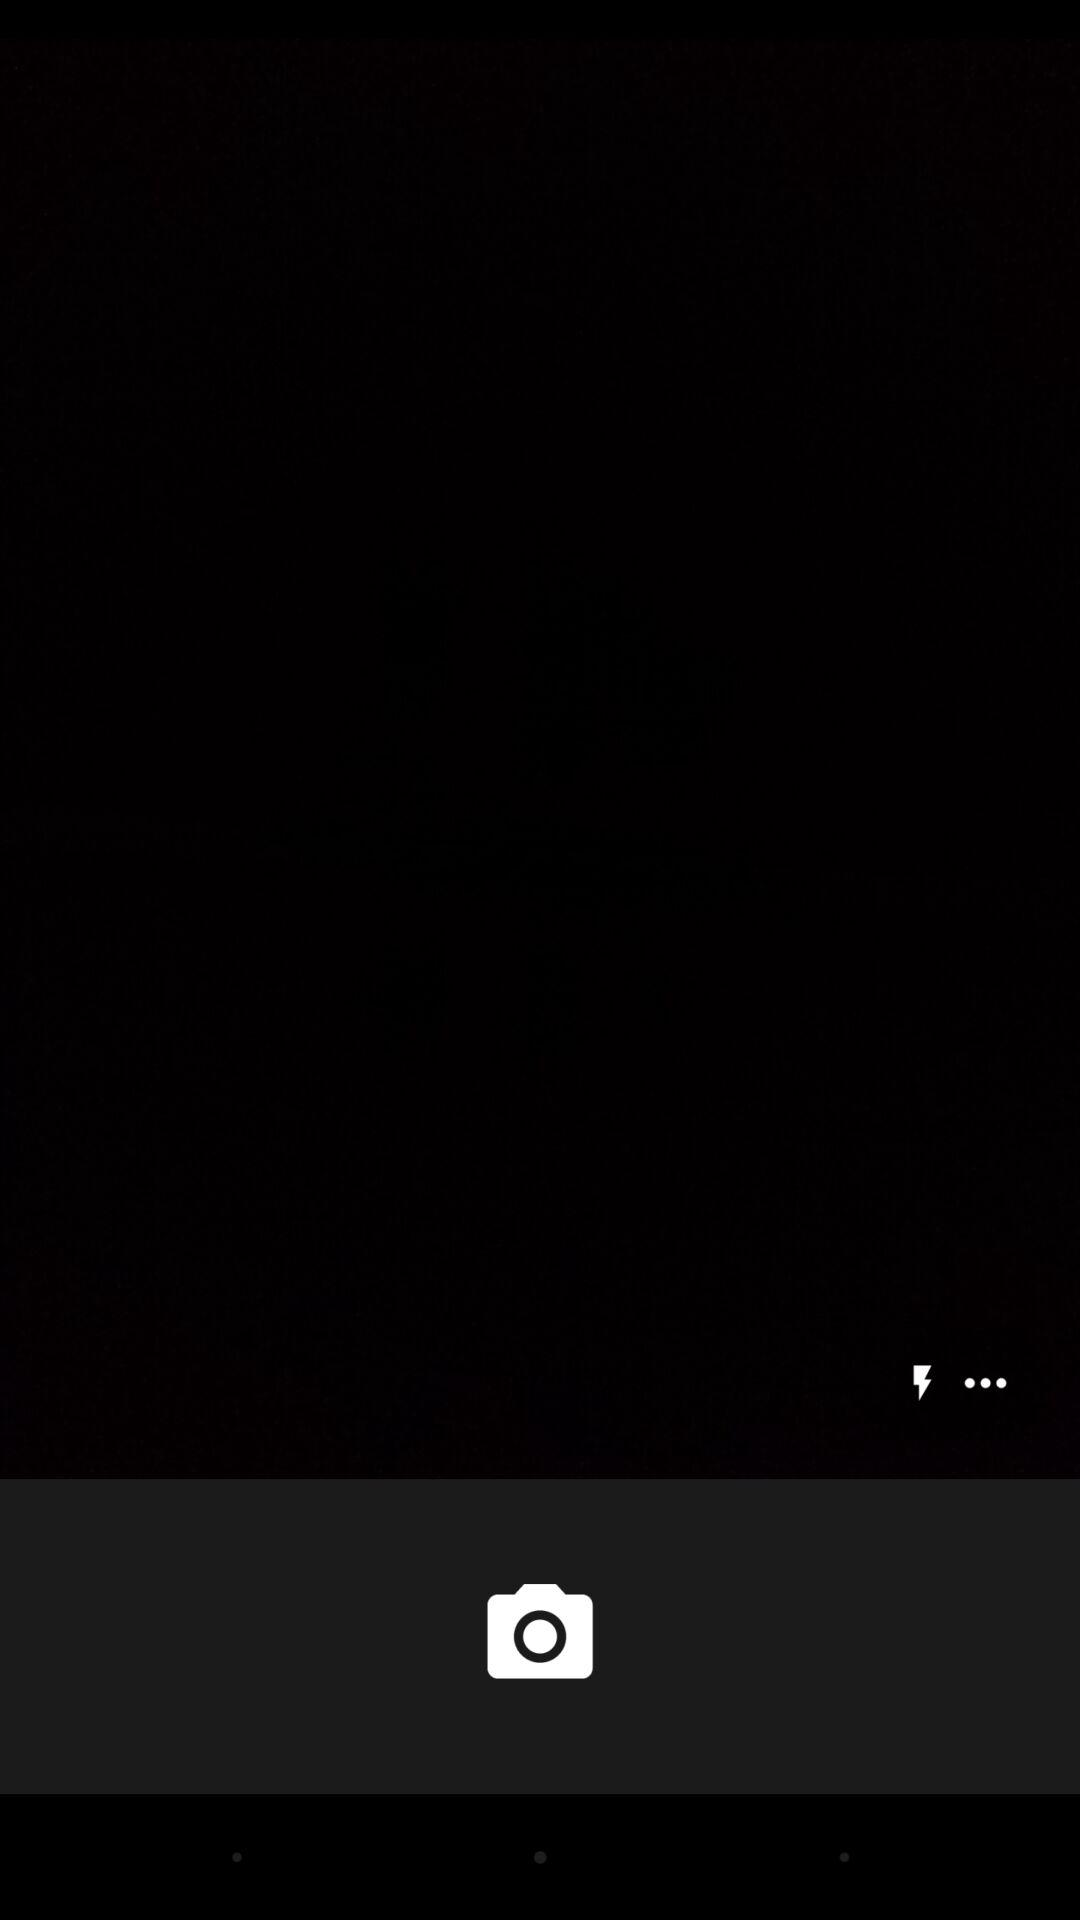How many more dots are there than lightning bolts?
Answer the question using a single word or phrase. 2 